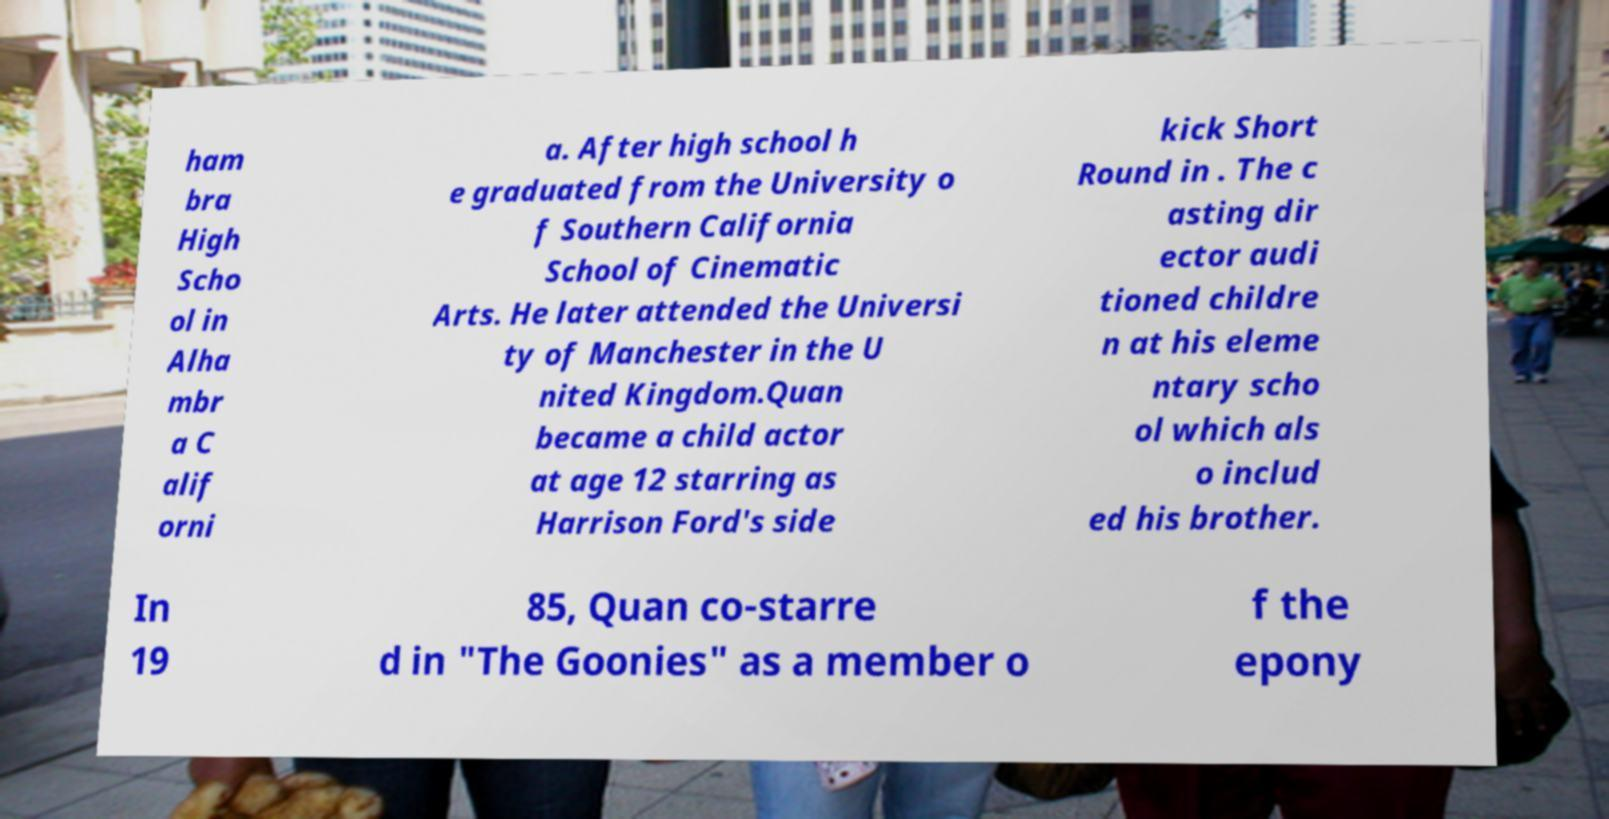Could you extract and type out the text from this image? ham bra High Scho ol in Alha mbr a C alif orni a. After high school h e graduated from the University o f Southern California School of Cinematic Arts. He later attended the Universi ty of Manchester in the U nited Kingdom.Quan became a child actor at age 12 starring as Harrison Ford's side kick Short Round in . The c asting dir ector audi tioned childre n at his eleme ntary scho ol which als o includ ed his brother. In 19 85, Quan co-starre d in "The Goonies" as a member o f the epony 